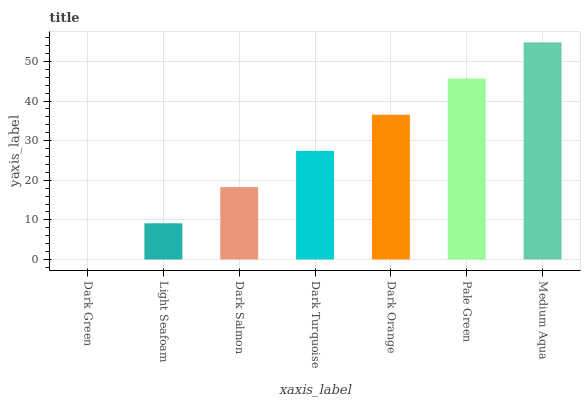Is Dark Green the minimum?
Answer yes or no. Yes. Is Medium Aqua the maximum?
Answer yes or no. Yes. Is Light Seafoam the minimum?
Answer yes or no. No. Is Light Seafoam the maximum?
Answer yes or no. No. Is Light Seafoam greater than Dark Green?
Answer yes or no. Yes. Is Dark Green less than Light Seafoam?
Answer yes or no. Yes. Is Dark Green greater than Light Seafoam?
Answer yes or no. No. Is Light Seafoam less than Dark Green?
Answer yes or no. No. Is Dark Turquoise the high median?
Answer yes or no. Yes. Is Dark Turquoise the low median?
Answer yes or no. Yes. Is Pale Green the high median?
Answer yes or no. No. Is Dark Salmon the low median?
Answer yes or no. No. 